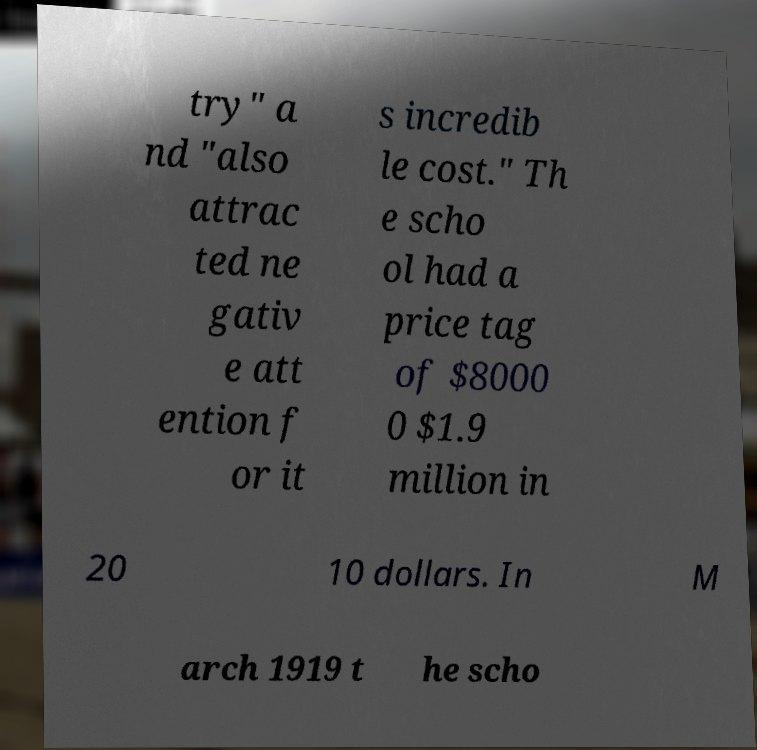What messages or text are displayed in this image? I need them in a readable, typed format. try" a nd "also attrac ted ne gativ e att ention f or it s incredib le cost." Th e scho ol had a price tag of $8000 0 $1.9 million in 20 10 dollars. In M arch 1919 t he scho 